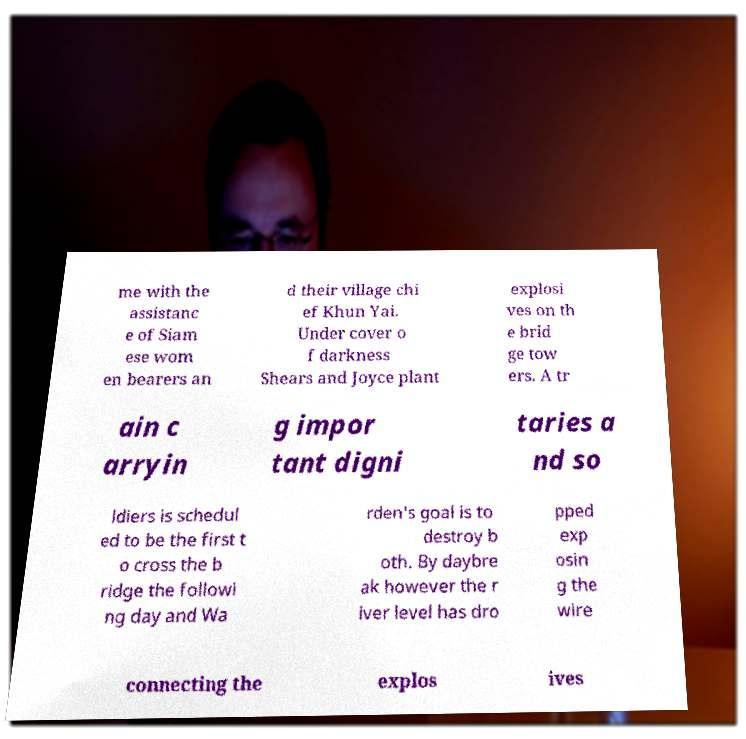What messages or text are displayed in this image? I need them in a readable, typed format. me with the assistanc e of Siam ese wom en bearers an d their village chi ef Khun Yai. Under cover o f darkness Shears and Joyce plant explosi ves on th e brid ge tow ers. A tr ain c arryin g impor tant digni taries a nd so ldiers is schedul ed to be the first t o cross the b ridge the followi ng day and Wa rden's goal is to destroy b oth. By daybre ak however the r iver level has dro pped exp osin g the wire connecting the explos ives 